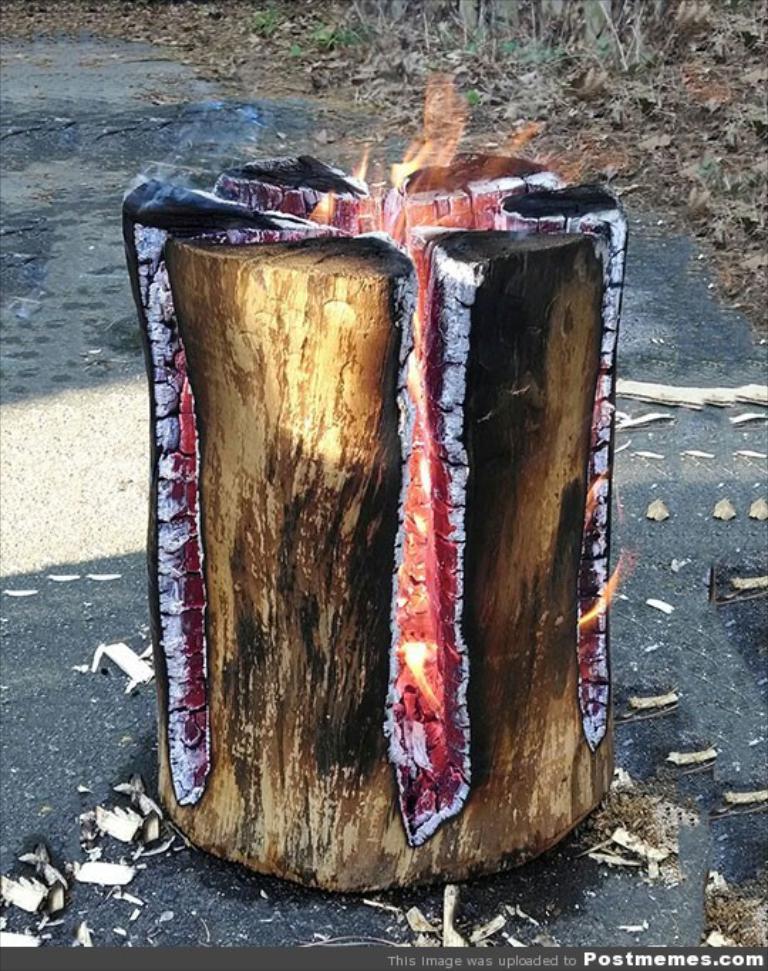Please provide a concise description of this image. In the center of the image we can see a fire log. In the background there are leaves and grass. 